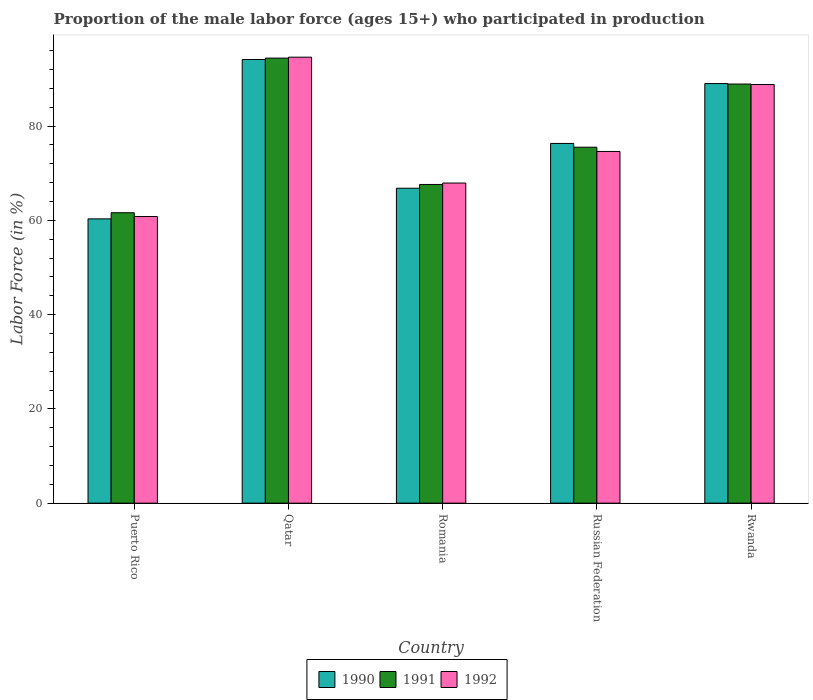How many bars are there on the 5th tick from the left?
Make the answer very short. 3. What is the label of the 5th group of bars from the left?
Your answer should be compact. Rwanda. In how many cases, is the number of bars for a given country not equal to the number of legend labels?
Your answer should be very brief. 0. What is the proportion of the male labor force who participated in production in 1992 in Russian Federation?
Offer a very short reply. 74.6. Across all countries, what is the maximum proportion of the male labor force who participated in production in 1992?
Provide a short and direct response. 94.6. Across all countries, what is the minimum proportion of the male labor force who participated in production in 1991?
Offer a very short reply. 61.6. In which country was the proportion of the male labor force who participated in production in 1990 maximum?
Ensure brevity in your answer.  Qatar. In which country was the proportion of the male labor force who participated in production in 1992 minimum?
Provide a short and direct response. Puerto Rico. What is the total proportion of the male labor force who participated in production in 1991 in the graph?
Provide a succinct answer. 388. What is the difference between the proportion of the male labor force who participated in production in 1990 in Romania and that in Russian Federation?
Keep it short and to the point. -9.5. What is the difference between the proportion of the male labor force who participated in production in 1990 in Rwanda and the proportion of the male labor force who participated in production in 1992 in Russian Federation?
Give a very brief answer. 14.4. What is the average proportion of the male labor force who participated in production in 1992 per country?
Keep it short and to the point. 77.34. What is the difference between the proportion of the male labor force who participated in production of/in 1990 and proportion of the male labor force who participated in production of/in 1992 in Qatar?
Your response must be concise. -0.5. In how many countries, is the proportion of the male labor force who participated in production in 1990 greater than 48 %?
Keep it short and to the point. 5. What is the ratio of the proportion of the male labor force who participated in production in 1991 in Puerto Rico to that in Qatar?
Provide a succinct answer. 0.65. Is the proportion of the male labor force who participated in production in 1990 in Puerto Rico less than that in Russian Federation?
Your answer should be compact. Yes. Is the difference between the proportion of the male labor force who participated in production in 1990 in Qatar and Russian Federation greater than the difference between the proportion of the male labor force who participated in production in 1992 in Qatar and Russian Federation?
Ensure brevity in your answer.  No. What is the difference between the highest and the second highest proportion of the male labor force who participated in production in 1991?
Provide a short and direct response. 13.4. What is the difference between the highest and the lowest proportion of the male labor force who participated in production in 1990?
Give a very brief answer. 33.8. In how many countries, is the proportion of the male labor force who participated in production in 1992 greater than the average proportion of the male labor force who participated in production in 1992 taken over all countries?
Your answer should be very brief. 2. Is the sum of the proportion of the male labor force who participated in production in 1991 in Qatar and Russian Federation greater than the maximum proportion of the male labor force who participated in production in 1990 across all countries?
Give a very brief answer. Yes. Are all the bars in the graph horizontal?
Give a very brief answer. No. Are the values on the major ticks of Y-axis written in scientific E-notation?
Keep it short and to the point. No. Does the graph contain any zero values?
Your answer should be very brief. No. Does the graph contain grids?
Keep it short and to the point. No. Where does the legend appear in the graph?
Keep it short and to the point. Bottom center. How many legend labels are there?
Your answer should be compact. 3. How are the legend labels stacked?
Make the answer very short. Horizontal. What is the title of the graph?
Give a very brief answer. Proportion of the male labor force (ages 15+) who participated in production. Does "2004" appear as one of the legend labels in the graph?
Your answer should be very brief. No. What is the Labor Force (in %) of 1990 in Puerto Rico?
Your answer should be very brief. 60.3. What is the Labor Force (in %) of 1991 in Puerto Rico?
Ensure brevity in your answer.  61.6. What is the Labor Force (in %) of 1992 in Puerto Rico?
Your response must be concise. 60.8. What is the Labor Force (in %) of 1990 in Qatar?
Provide a succinct answer. 94.1. What is the Labor Force (in %) of 1991 in Qatar?
Provide a succinct answer. 94.4. What is the Labor Force (in %) of 1992 in Qatar?
Your response must be concise. 94.6. What is the Labor Force (in %) in 1990 in Romania?
Offer a terse response. 66.8. What is the Labor Force (in %) in 1991 in Romania?
Make the answer very short. 67.6. What is the Labor Force (in %) in 1992 in Romania?
Make the answer very short. 67.9. What is the Labor Force (in %) of 1990 in Russian Federation?
Your response must be concise. 76.3. What is the Labor Force (in %) in 1991 in Russian Federation?
Your answer should be very brief. 75.5. What is the Labor Force (in %) of 1992 in Russian Federation?
Keep it short and to the point. 74.6. What is the Labor Force (in %) in 1990 in Rwanda?
Keep it short and to the point. 89. What is the Labor Force (in %) of 1991 in Rwanda?
Keep it short and to the point. 88.9. What is the Labor Force (in %) in 1992 in Rwanda?
Offer a very short reply. 88.8. Across all countries, what is the maximum Labor Force (in %) of 1990?
Keep it short and to the point. 94.1. Across all countries, what is the maximum Labor Force (in %) of 1991?
Your response must be concise. 94.4. Across all countries, what is the maximum Labor Force (in %) of 1992?
Provide a short and direct response. 94.6. Across all countries, what is the minimum Labor Force (in %) in 1990?
Your response must be concise. 60.3. Across all countries, what is the minimum Labor Force (in %) in 1991?
Provide a succinct answer. 61.6. Across all countries, what is the minimum Labor Force (in %) in 1992?
Offer a very short reply. 60.8. What is the total Labor Force (in %) in 1990 in the graph?
Ensure brevity in your answer.  386.5. What is the total Labor Force (in %) in 1991 in the graph?
Keep it short and to the point. 388. What is the total Labor Force (in %) in 1992 in the graph?
Make the answer very short. 386.7. What is the difference between the Labor Force (in %) in 1990 in Puerto Rico and that in Qatar?
Offer a very short reply. -33.8. What is the difference between the Labor Force (in %) of 1991 in Puerto Rico and that in Qatar?
Offer a very short reply. -32.8. What is the difference between the Labor Force (in %) of 1992 in Puerto Rico and that in Qatar?
Keep it short and to the point. -33.8. What is the difference between the Labor Force (in %) of 1990 in Puerto Rico and that in Romania?
Ensure brevity in your answer.  -6.5. What is the difference between the Labor Force (in %) of 1990 in Puerto Rico and that in Rwanda?
Make the answer very short. -28.7. What is the difference between the Labor Force (in %) in 1991 in Puerto Rico and that in Rwanda?
Your answer should be very brief. -27.3. What is the difference between the Labor Force (in %) of 1990 in Qatar and that in Romania?
Your response must be concise. 27.3. What is the difference between the Labor Force (in %) of 1991 in Qatar and that in Romania?
Give a very brief answer. 26.8. What is the difference between the Labor Force (in %) of 1992 in Qatar and that in Romania?
Offer a terse response. 26.7. What is the difference between the Labor Force (in %) of 1990 in Qatar and that in Russian Federation?
Make the answer very short. 17.8. What is the difference between the Labor Force (in %) of 1991 in Qatar and that in Russian Federation?
Provide a succinct answer. 18.9. What is the difference between the Labor Force (in %) of 1990 in Qatar and that in Rwanda?
Ensure brevity in your answer.  5.1. What is the difference between the Labor Force (in %) in 1990 in Romania and that in Russian Federation?
Your response must be concise. -9.5. What is the difference between the Labor Force (in %) of 1990 in Romania and that in Rwanda?
Provide a succinct answer. -22.2. What is the difference between the Labor Force (in %) in 1991 in Romania and that in Rwanda?
Offer a terse response. -21.3. What is the difference between the Labor Force (in %) of 1992 in Romania and that in Rwanda?
Provide a succinct answer. -20.9. What is the difference between the Labor Force (in %) in 1990 in Russian Federation and that in Rwanda?
Provide a succinct answer. -12.7. What is the difference between the Labor Force (in %) of 1990 in Puerto Rico and the Labor Force (in %) of 1991 in Qatar?
Offer a terse response. -34.1. What is the difference between the Labor Force (in %) in 1990 in Puerto Rico and the Labor Force (in %) in 1992 in Qatar?
Offer a terse response. -34.3. What is the difference between the Labor Force (in %) in 1991 in Puerto Rico and the Labor Force (in %) in 1992 in Qatar?
Your answer should be compact. -33. What is the difference between the Labor Force (in %) of 1990 in Puerto Rico and the Labor Force (in %) of 1991 in Romania?
Your answer should be very brief. -7.3. What is the difference between the Labor Force (in %) in 1991 in Puerto Rico and the Labor Force (in %) in 1992 in Romania?
Make the answer very short. -6.3. What is the difference between the Labor Force (in %) of 1990 in Puerto Rico and the Labor Force (in %) of 1991 in Russian Federation?
Your answer should be compact. -15.2. What is the difference between the Labor Force (in %) in 1990 in Puerto Rico and the Labor Force (in %) in 1992 in Russian Federation?
Provide a succinct answer. -14.3. What is the difference between the Labor Force (in %) in 1991 in Puerto Rico and the Labor Force (in %) in 1992 in Russian Federation?
Your answer should be very brief. -13. What is the difference between the Labor Force (in %) of 1990 in Puerto Rico and the Labor Force (in %) of 1991 in Rwanda?
Give a very brief answer. -28.6. What is the difference between the Labor Force (in %) in 1990 in Puerto Rico and the Labor Force (in %) in 1992 in Rwanda?
Your answer should be very brief. -28.5. What is the difference between the Labor Force (in %) in 1991 in Puerto Rico and the Labor Force (in %) in 1992 in Rwanda?
Make the answer very short. -27.2. What is the difference between the Labor Force (in %) in 1990 in Qatar and the Labor Force (in %) in 1992 in Romania?
Offer a terse response. 26.2. What is the difference between the Labor Force (in %) of 1990 in Qatar and the Labor Force (in %) of 1991 in Russian Federation?
Your response must be concise. 18.6. What is the difference between the Labor Force (in %) of 1990 in Qatar and the Labor Force (in %) of 1992 in Russian Federation?
Ensure brevity in your answer.  19.5. What is the difference between the Labor Force (in %) of 1991 in Qatar and the Labor Force (in %) of 1992 in Russian Federation?
Provide a short and direct response. 19.8. What is the difference between the Labor Force (in %) in 1990 in Qatar and the Labor Force (in %) in 1991 in Rwanda?
Your response must be concise. 5.2. What is the difference between the Labor Force (in %) of 1990 in Qatar and the Labor Force (in %) of 1992 in Rwanda?
Keep it short and to the point. 5.3. What is the difference between the Labor Force (in %) in 1991 in Qatar and the Labor Force (in %) in 1992 in Rwanda?
Offer a terse response. 5.6. What is the difference between the Labor Force (in %) of 1990 in Romania and the Labor Force (in %) of 1991 in Russian Federation?
Keep it short and to the point. -8.7. What is the difference between the Labor Force (in %) in 1990 in Romania and the Labor Force (in %) in 1992 in Russian Federation?
Offer a very short reply. -7.8. What is the difference between the Labor Force (in %) of 1991 in Romania and the Labor Force (in %) of 1992 in Russian Federation?
Make the answer very short. -7. What is the difference between the Labor Force (in %) in 1990 in Romania and the Labor Force (in %) in 1991 in Rwanda?
Keep it short and to the point. -22.1. What is the difference between the Labor Force (in %) of 1991 in Romania and the Labor Force (in %) of 1992 in Rwanda?
Keep it short and to the point. -21.2. What is the difference between the Labor Force (in %) in 1990 in Russian Federation and the Labor Force (in %) in 1991 in Rwanda?
Provide a short and direct response. -12.6. What is the difference between the Labor Force (in %) in 1991 in Russian Federation and the Labor Force (in %) in 1992 in Rwanda?
Give a very brief answer. -13.3. What is the average Labor Force (in %) of 1990 per country?
Ensure brevity in your answer.  77.3. What is the average Labor Force (in %) of 1991 per country?
Provide a succinct answer. 77.6. What is the average Labor Force (in %) in 1992 per country?
Your answer should be very brief. 77.34. What is the difference between the Labor Force (in %) in 1990 and Labor Force (in %) in 1992 in Puerto Rico?
Make the answer very short. -0.5. What is the difference between the Labor Force (in %) in 1991 and Labor Force (in %) in 1992 in Qatar?
Your answer should be compact. -0.2. What is the difference between the Labor Force (in %) of 1990 and Labor Force (in %) of 1992 in Romania?
Your answer should be very brief. -1.1. What is the difference between the Labor Force (in %) in 1991 and Labor Force (in %) in 1992 in Romania?
Provide a short and direct response. -0.3. What is the difference between the Labor Force (in %) of 1990 and Labor Force (in %) of 1991 in Russian Federation?
Your answer should be very brief. 0.8. What is the difference between the Labor Force (in %) of 1990 and Labor Force (in %) of 1992 in Russian Federation?
Offer a terse response. 1.7. What is the difference between the Labor Force (in %) in 1991 and Labor Force (in %) in 1992 in Rwanda?
Give a very brief answer. 0.1. What is the ratio of the Labor Force (in %) of 1990 in Puerto Rico to that in Qatar?
Keep it short and to the point. 0.64. What is the ratio of the Labor Force (in %) in 1991 in Puerto Rico to that in Qatar?
Your response must be concise. 0.65. What is the ratio of the Labor Force (in %) in 1992 in Puerto Rico to that in Qatar?
Give a very brief answer. 0.64. What is the ratio of the Labor Force (in %) in 1990 in Puerto Rico to that in Romania?
Keep it short and to the point. 0.9. What is the ratio of the Labor Force (in %) in 1991 in Puerto Rico to that in Romania?
Offer a very short reply. 0.91. What is the ratio of the Labor Force (in %) of 1992 in Puerto Rico to that in Romania?
Your response must be concise. 0.9. What is the ratio of the Labor Force (in %) of 1990 in Puerto Rico to that in Russian Federation?
Offer a very short reply. 0.79. What is the ratio of the Labor Force (in %) in 1991 in Puerto Rico to that in Russian Federation?
Provide a succinct answer. 0.82. What is the ratio of the Labor Force (in %) in 1992 in Puerto Rico to that in Russian Federation?
Your answer should be compact. 0.81. What is the ratio of the Labor Force (in %) of 1990 in Puerto Rico to that in Rwanda?
Make the answer very short. 0.68. What is the ratio of the Labor Force (in %) of 1991 in Puerto Rico to that in Rwanda?
Your answer should be very brief. 0.69. What is the ratio of the Labor Force (in %) of 1992 in Puerto Rico to that in Rwanda?
Your answer should be compact. 0.68. What is the ratio of the Labor Force (in %) of 1990 in Qatar to that in Romania?
Keep it short and to the point. 1.41. What is the ratio of the Labor Force (in %) of 1991 in Qatar to that in Romania?
Make the answer very short. 1.4. What is the ratio of the Labor Force (in %) in 1992 in Qatar to that in Romania?
Provide a succinct answer. 1.39. What is the ratio of the Labor Force (in %) in 1990 in Qatar to that in Russian Federation?
Provide a succinct answer. 1.23. What is the ratio of the Labor Force (in %) in 1991 in Qatar to that in Russian Federation?
Provide a short and direct response. 1.25. What is the ratio of the Labor Force (in %) of 1992 in Qatar to that in Russian Federation?
Provide a short and direct response. 1.27. What is the ratio of the Labor Force (in %) of 1990 in Qatar to that in Rwanda?
Offer a very short reply. 1.06. What is the ratio of the Labor Force (in %) in 1991 in Qatar to that in Rwanda?
Provide a succinct answer. 1.06. What is the ratio of the Labor Force (in %) in 1992 in Qatar to that in Rwanda?
Your answer should be compact. 1.07. What is the ratio of the Labor Force (in %) of 1990 in Romania to that in Russian Federation?
Ensure brevity in your answer.  0.88. What is the ratio of the Labor Force (in %) of 1991 in Romania to that in Russian Federation?
Offer a very short reply. 0.9. What is the ratio of the Labor Force (in %) of 1992 in Romania to that in Russian Federation?
Provide a short and direct response. 0.91. What is the ratio of the Labor Force (in %) of 1990 in Romania to that in Rwanda?
Your answer should be compact. 0.75. What is the ratio of the Labor Force (in %) in 1991 in Romania to that in Rwanda?
Your response must be concise. 0.76. What is the ratio of the Labor Force (in %) in 1992 in Romania to that in Rwanda?
Your answer should be very brief. 0.76. What is the ratio of the Labor Force (in %) of 1990 in Russian Federation to that in Rwanda?
Provide a succinct answer. 0.86. What is the ratio of the Labor Force (in %) of 1991 in Russian Federation to that in Rwanda?
Ensure brevity in your answer.  0.85. What is the ratio of the Labor Force (in %) of 1992 in Russian Federation to that in Rwanda?
Your response must be concise. 0.84. What is the difference between the highest and the second highest Labor Force (in %) of 1990?
Give a very brief answer. 5.1. What is the difference between the highest and the second highest Labor Force (in %) in 1991?
Ensure brevity in your answer.  5.5. What is the difference between the highest and the second highest Labor Force (in %) in 1992?
Give a very brief answer. 5.8. What is the difference between the highest and the lowest Labor Force (in %) of 1990?
Your answer should be very brief. 33.8. What is the difference between the highest and the lowest Labor Force (in %) in 1991?
Your answer should be compact. 32.8. What is the difference between the highest and the lowest Labor Force (in %) in 1992?
Your answer should be very brief. 33.8. 